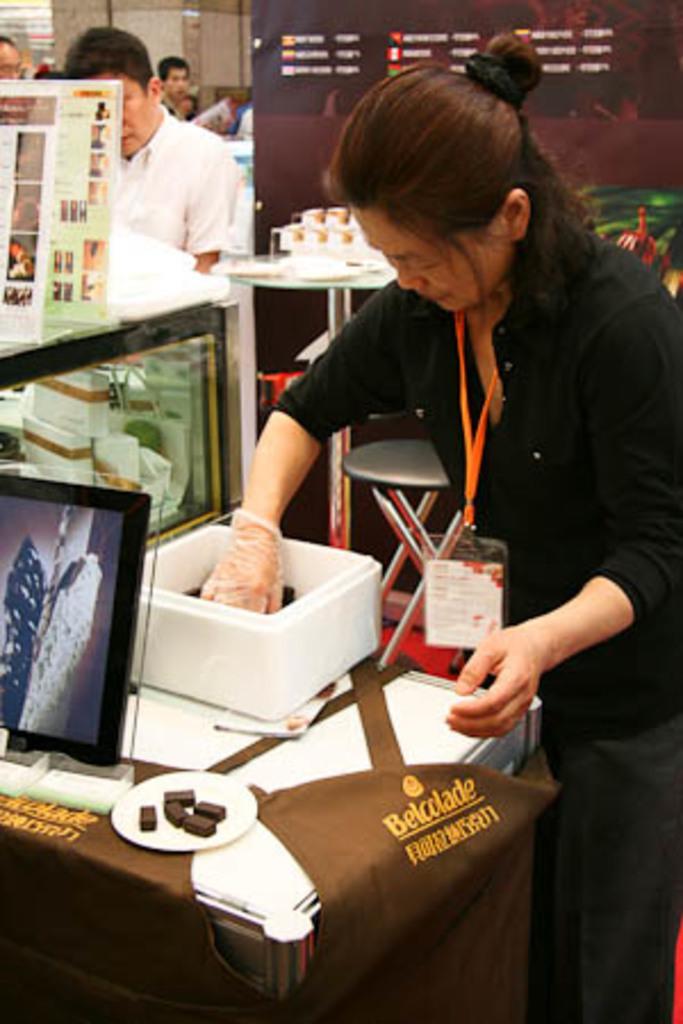Can you describe this image briefly? In this image we can see a woman wearing a black dress and aid card is standing in front of a table. In which a box, photo frame and a plate containing food is placed on it. To the left side of the image we can see glass box containing different boxes and in the background, we can see a group of people standing. 